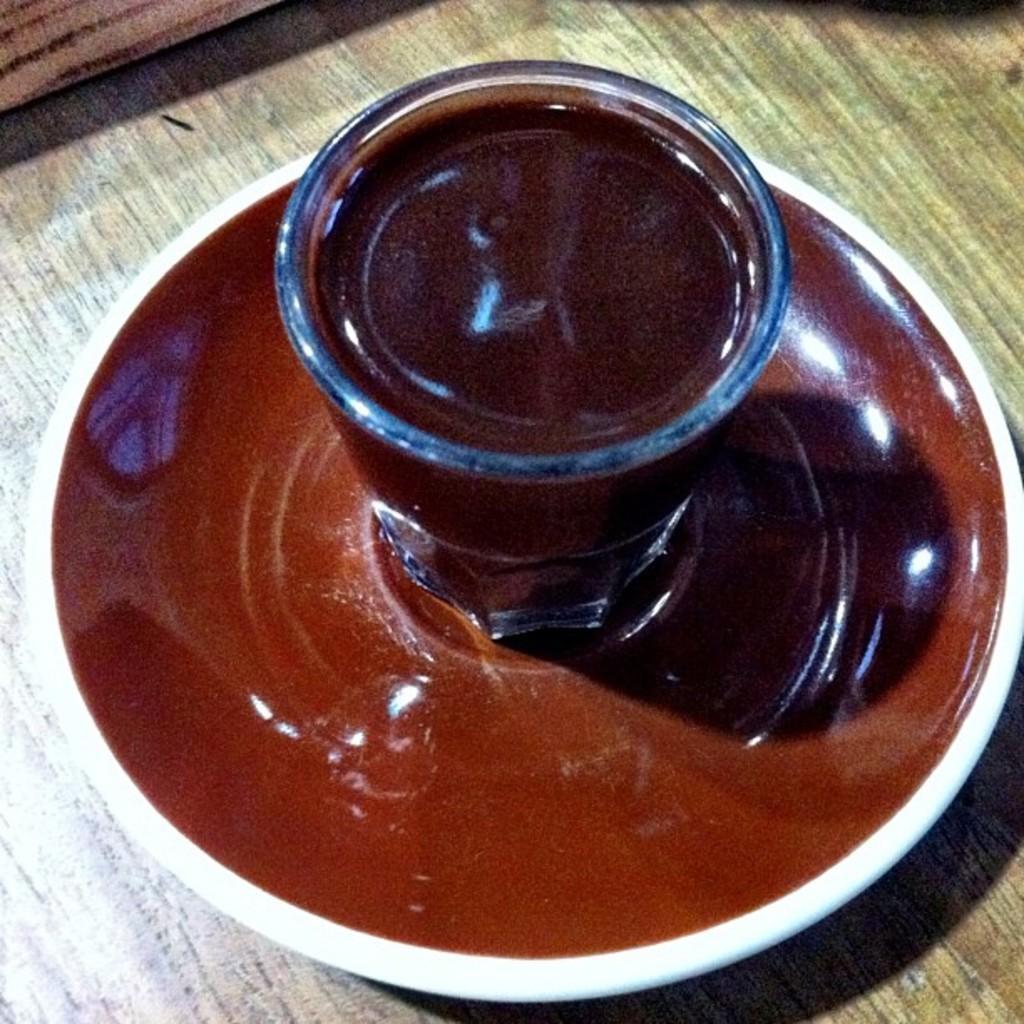In one or two sentences, can you explain what this image depicts? In this picture we can see a table. On the table we can see a plate, glass which contains liquid. 